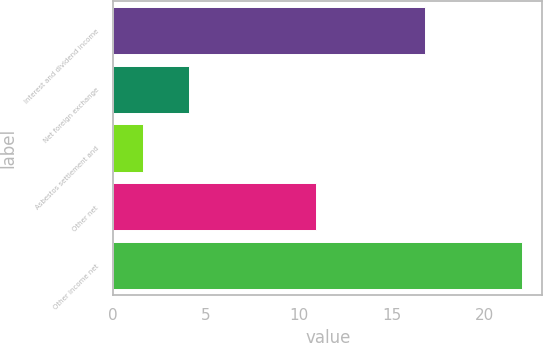Convert chart. <chart><loc_0><loc_0><loc_500><loc_500><bar_chart><fcel>Interest and dividend income<fcel>Net foreign exchange<fcel>Asbestos settlement and<fcel>Other net<fcel>Other income net<nl><fcel>16.8<fcel>4.1<fcel>1.6<fcel>10.9<fcel>22<nl></chart> 